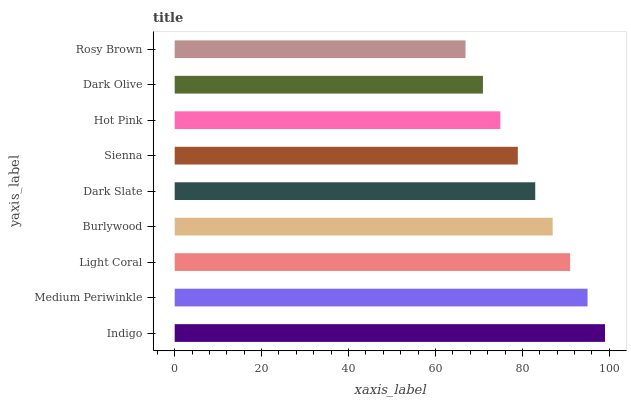Is Rosy Brown the minimum?
Answer yes or no. Yes. Is Indigo the maximum?
Answer yes or no. Yes. Is Medium Periwinkle the minimum?
Answer yes or no. No. Is Medium Periwinkle the maximum?
Answer yes or no. No. Is Indigo greater than Medium Periwinkle?
Answer yes or no. Yes. Is Medium Periwinkle less than Indigo?
Answer yes or no. Yes. Is Medium Periwinkle greater than Indigo?
Answer yes or no. No. Is Indigo less than Medium Periwinkle?
Answer yes or no. No. Is Dark Slate the high median?
Answer yes or no. Yes. Is Dark Slate the low median?
Answer yes or no. Yes. Is Indigo the high median?
Answer yes or no. No. Is Light Coral the low median?
Answer yes or no. No. 